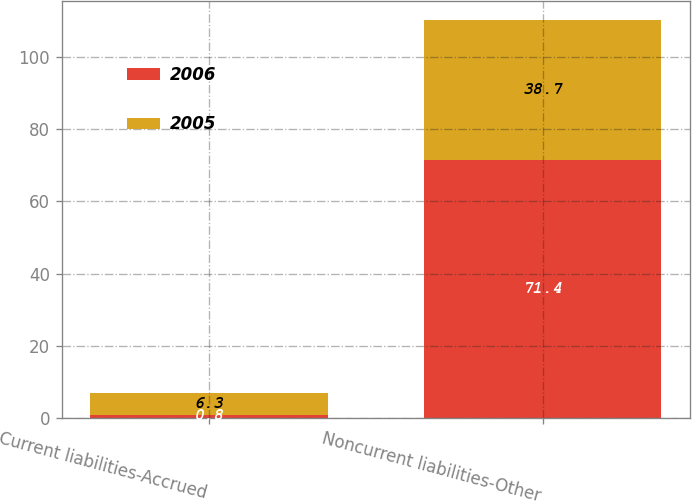Convert chart. <chart><loc_0><loc_0><loc_500><loc_500><stacked_bar_chart><ecel><fcel>Current liabilities-Accrued<fcel>Noncurrent liabilities-Other<nl><fcel>2006<fcel>0.8<fcel>71.4<nl><fcel>2005<fcel>6.3<fcel>38.7<nl></chart> 